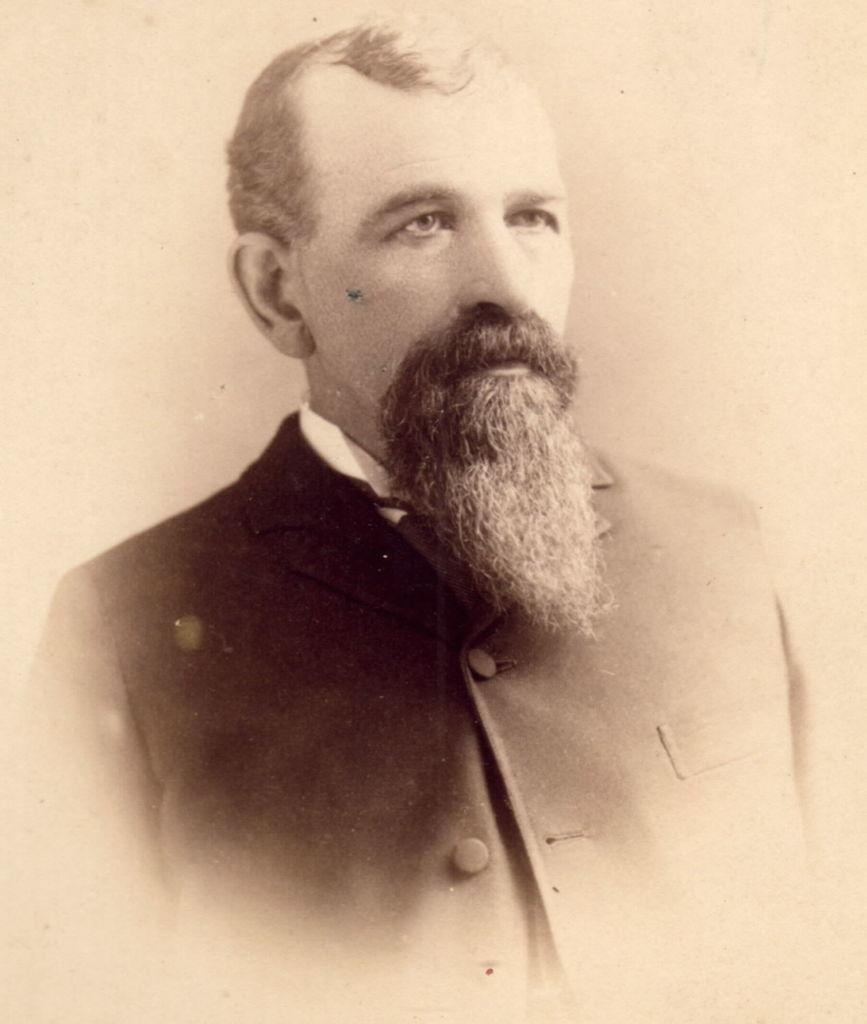What is present in the image? There is a man in the image. Can you describe the man's attire? The man is wearing clothes. Can you see any waves in the image? There are no waves present in the image; it only features a man wearing clothes. 